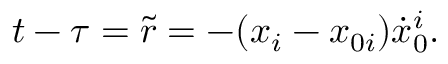Convert formula to latex. <formula><loc_0><loc_0><loc_500><loc_500>t - \tau = \tilde { r } = - ( x _ { i } - x _ { 0 i } ) { \dot { x } } _ { 0 } ^ { i } .</formula> 